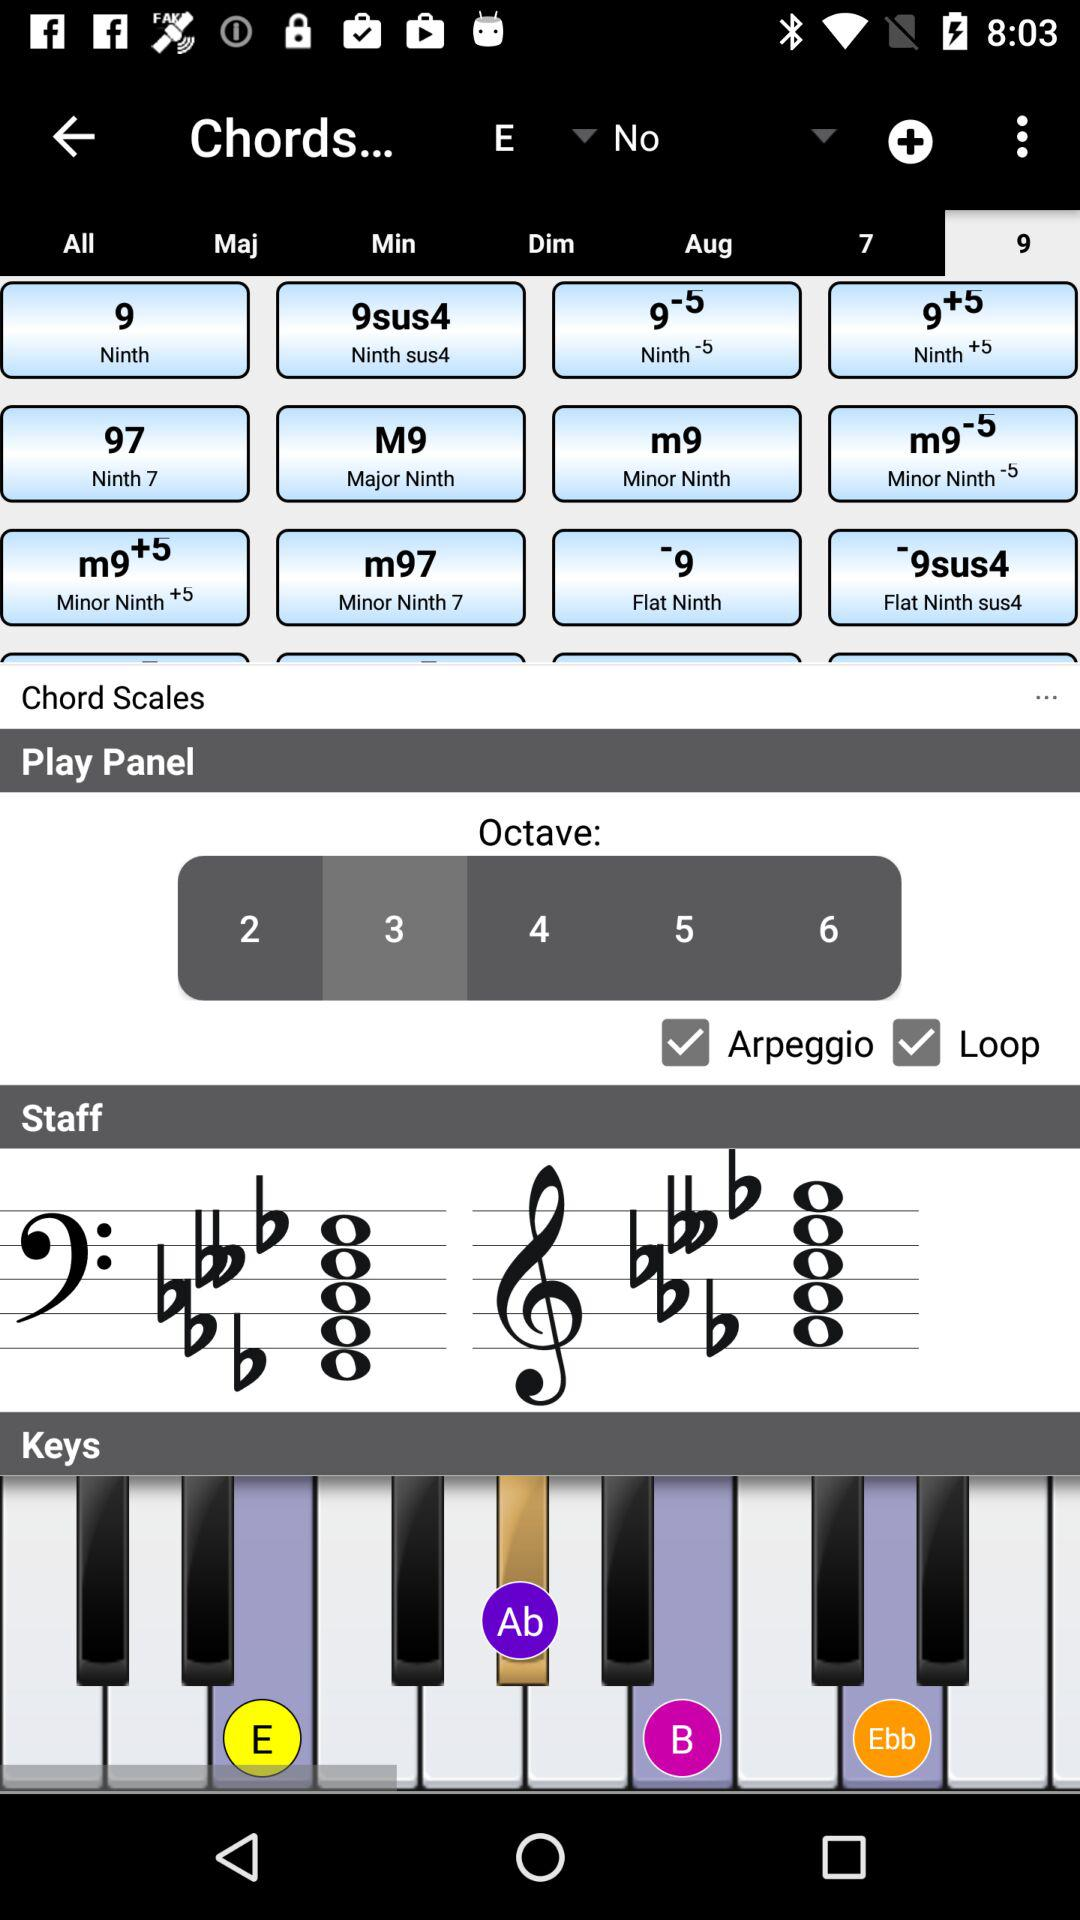Is "Chord Scales" checked or unchecked?
When the provided information is insufficient, respond with <no answer>. <no answer> 